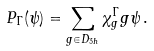<formula> <loc_0><loc_0><loc_500><loc_500>P _ { \Gamma } ( \psi ) = \sum _ { g \in D _ { 3 h } } \chi ^ { \Gamma } _ { g } g \psi \, .</formula> 